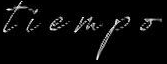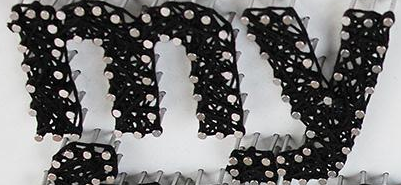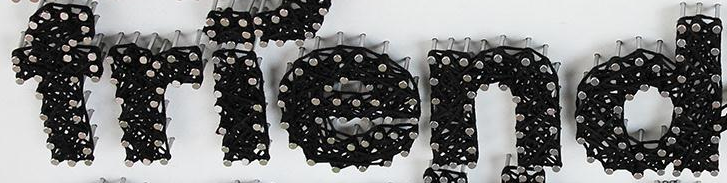Read the text from these images in sequence, separated by a semicolon. tiempo; my; friend 